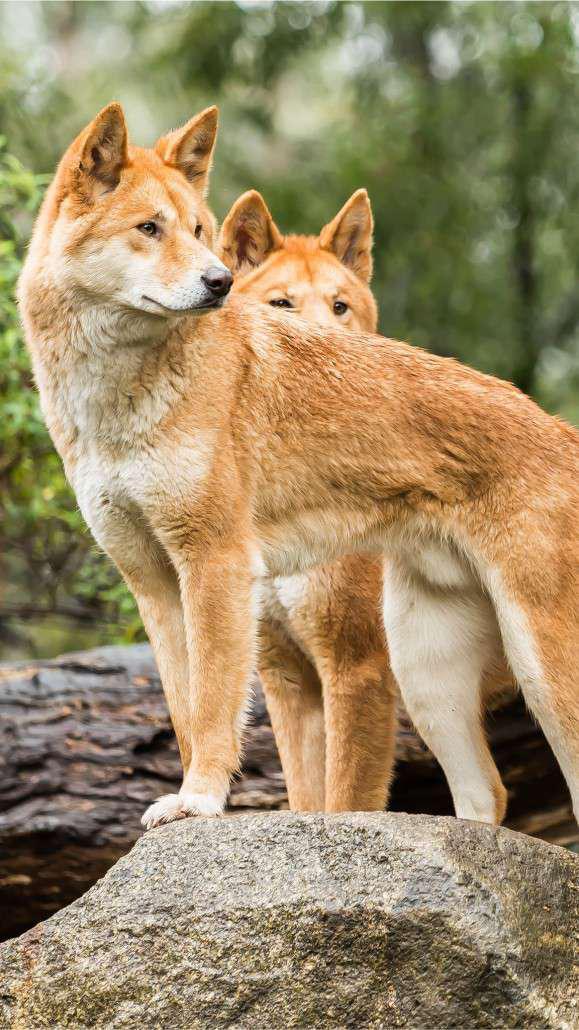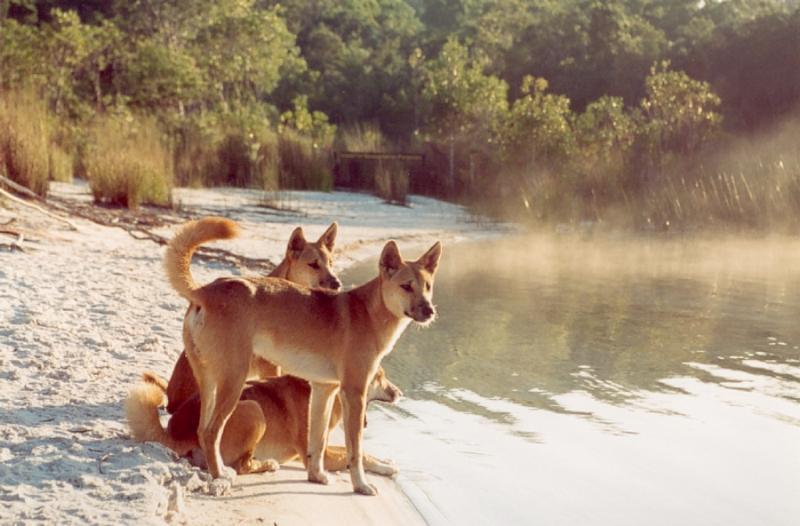The first image is the image on the left, the second image is the image on the right. Given the left and right images, does the statement "There are only two dogs and both are looking in different directions." hold true? Answer yes or no. No. The first image is the image on the left, the second image is the image on the right. For the images shown, is this caption "Each photo shows a single dingo in the wild." true? Answer yes or no. No. 